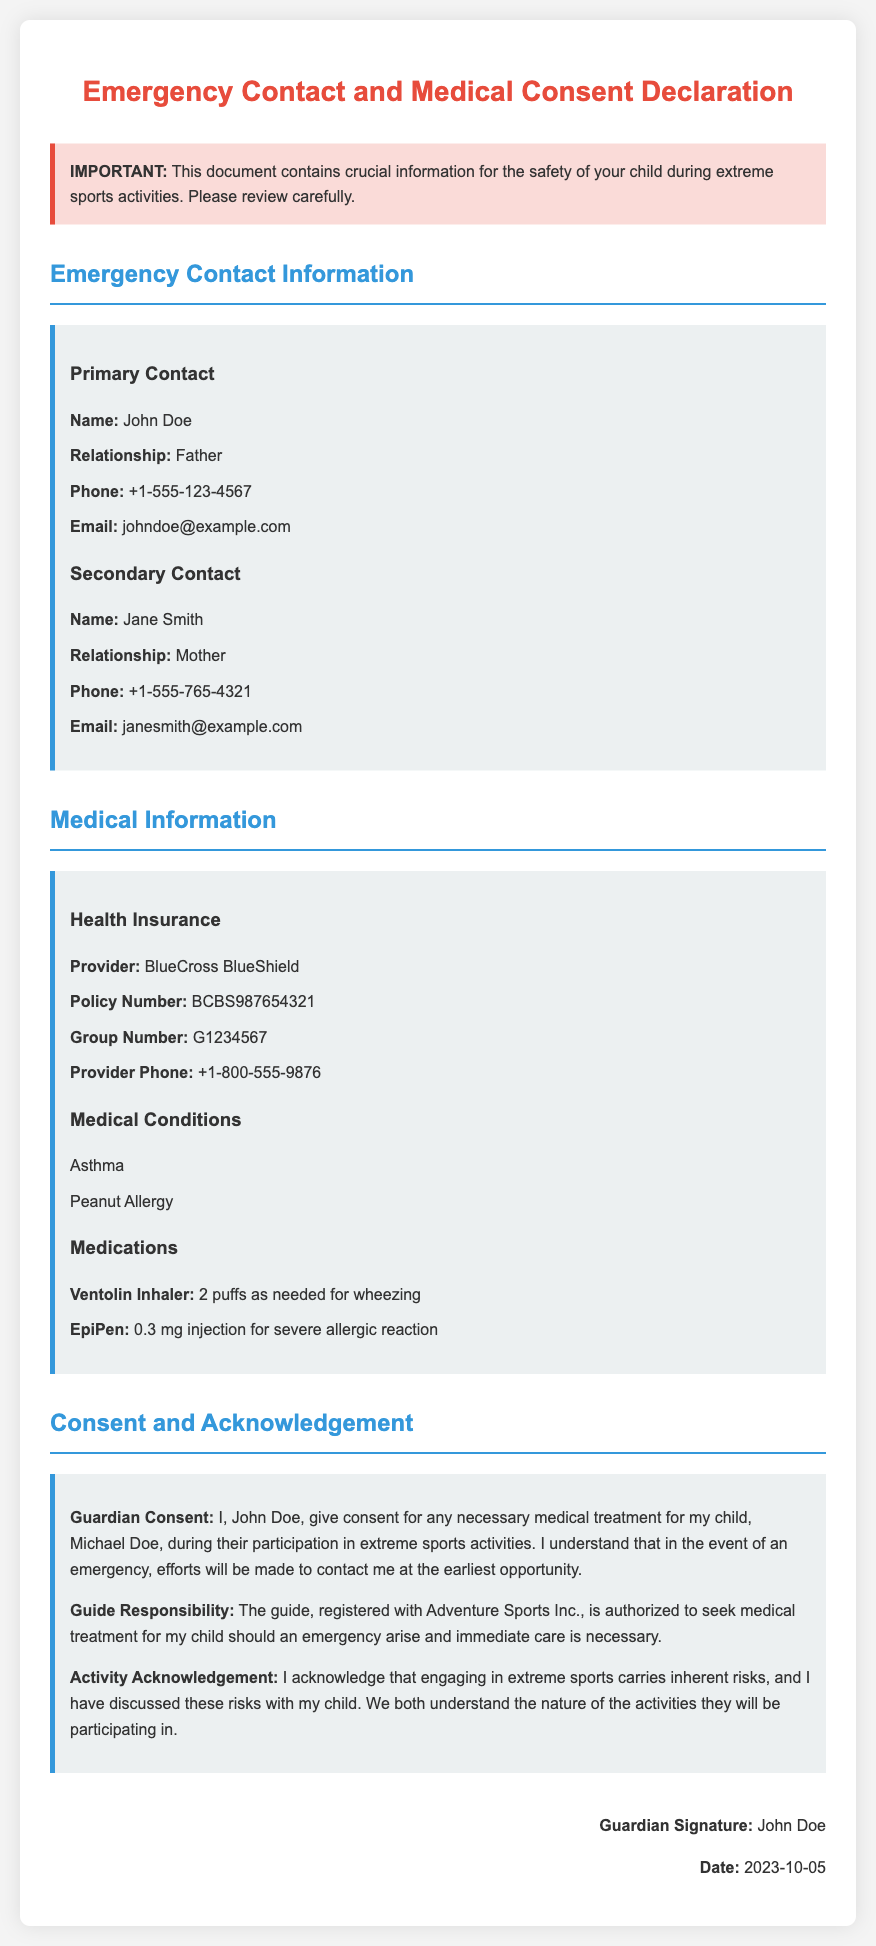What is the primary contact's name? The primary contact listed in the document is the person to be contacted first in case of an emergency, which is John Doe.
Answer: John Doe What is the policy number for health insurance? The policy number is crucial for the health insurance provider to identify the coverage for medical treatment, which is BCBS987654321.
Answer: BCBS987654321 What medical condition does the child have related to allergies? The document lists specific medical conditions, including allergies, which are important for care during activities, such as Peanut Allergy.
Answer: Peanut Allergy How many puffs of the Ventolin Inhaler can be given as needed? The number of puffs indicated in the document provides specific guidance for emergency use, which is 2 puffs.
Answer: 2 puffs Who is authorized to seek medical treatment for the child in an emergency? The document outlines the responsibility of the guide, specifying who will act in case of a medical emergency; this is Adventure Sports Inc.
Answer: Adventure Sports Inc What date was the guardian's consent signed? The date indicates when the guardian acknowledged and signed the document, which is significant for record-keeping, that date is 2023-10-05.
Answer: 2023-10-05 What is the relationship of the secondary contact to the child? The relationship provides context on who else can be contacted in an emergency, which is Mother.
Answer: Mother What is the provider phone number for health insurance? This number is essential for contacting the health insurance company in emergencies, which is +1-800-555-9876.
Answer: +1-800-555-9876 